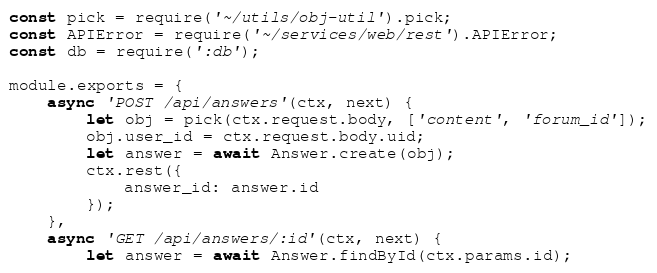<code> <loc_0><loc_0><loc_500><loc_500><_JavaScript_>const pick = require('~/utils/obj-util').pick;
const APIError = require('~/services/web/rest').APIError;
const db = require(':db');

module.exports = {
    async 'POST /api/answers'(ctx, next) {
        let obj = pick(ctx.request.body, ['content', 'forum_id']);
        obj.user_id = ctx.request.body.uid;
        let answer = await Answer.create(obj);
        ctx.rest({
            answer_id: answer.id
        });
    },
    async 'GET /api/answers/:id'(ctx, next) {
        let answer = await Answer.findById(ctx.params.id);</code> 